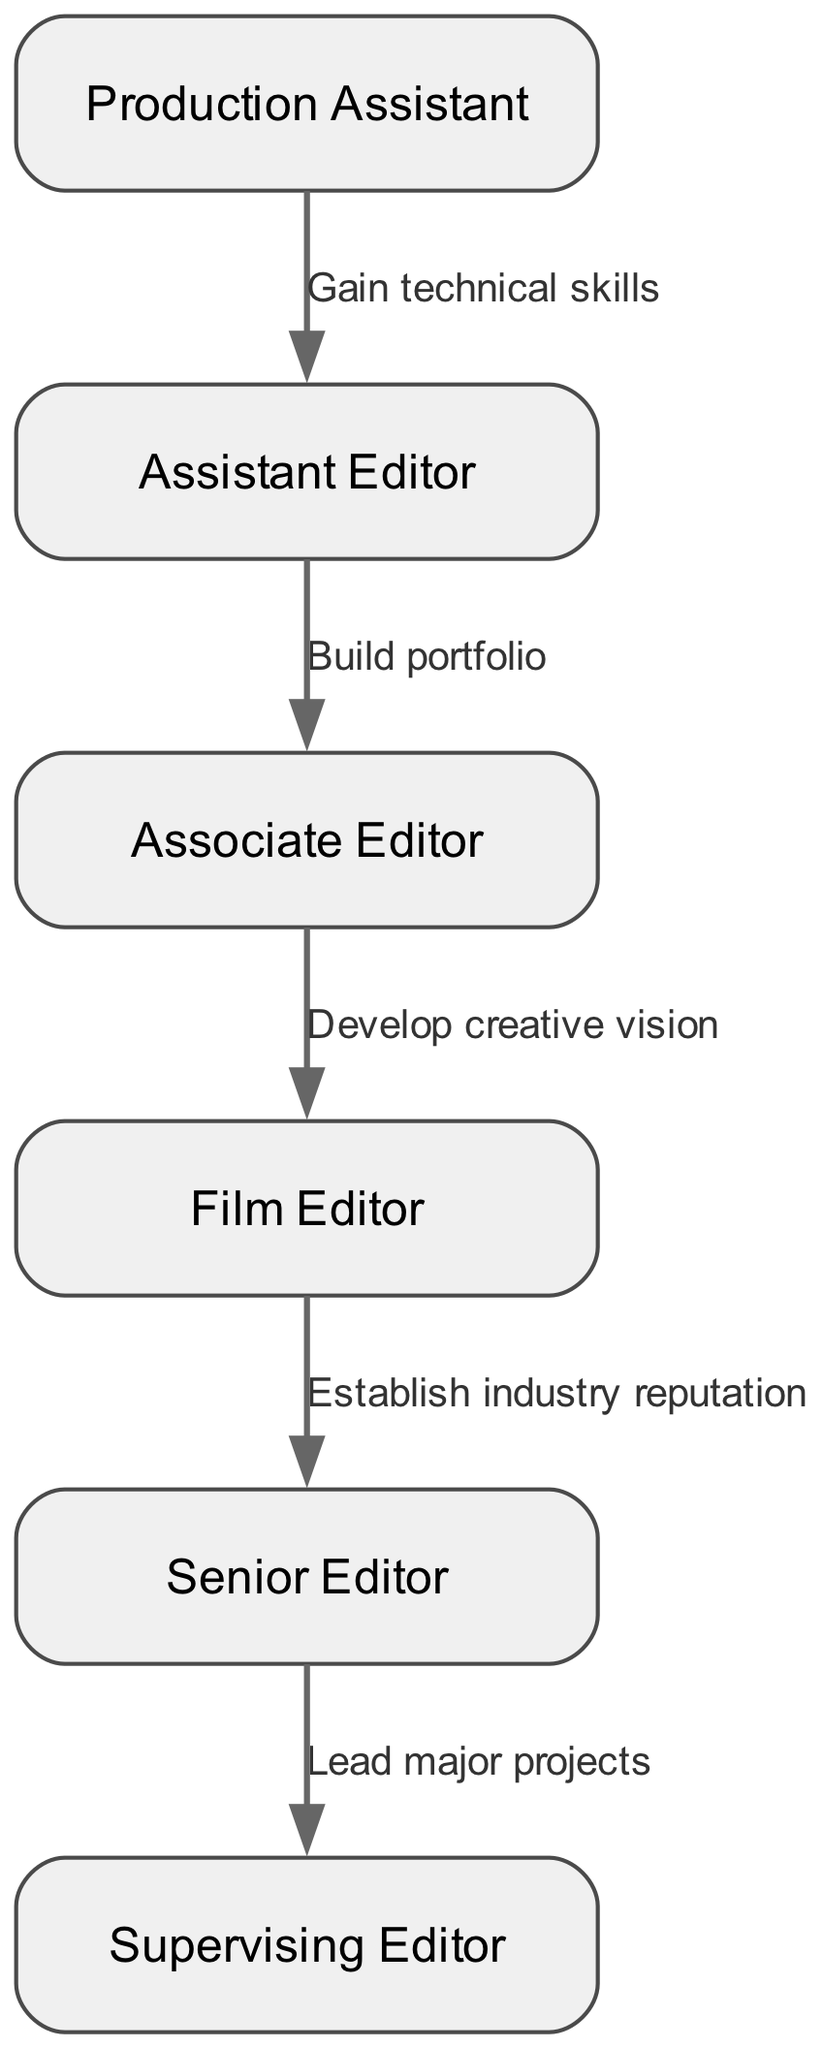What is the first role in the progression path? The diagram shows the career progression starting with the node labeled "Production Assistant", which is the initial role for aspiring film industry professionals.
Answer: Production Assistant How many nodes are in the diagram? By counting the nodes listed, we find there are six: Production Assistant, Assistant Editor, Associate Editor, Film Editor, Senior Editor, and Supervising Editor.
Answer: Six What skill is needed to move from Production Assistant to Assistant Editor? The edge connecting these two nodes indicates that one must "Gain technical skills" to progress from a Production Assistant to an Assistant Editor.
Answer: Gain technical skills What is the last role before becoming a Supervising Editor? The last node before the edge leading to Supervising Editor is labeled "Senior Editor," based on the direct connection illustrated in the diagram.
Answer: Senior Editor What must an Assistant Editor do to progress to an Associate Editor? The connection between the Assistant Editor and Associate Editor notes that one must "Build portfolio" to achieve advancement to the Associate Editor role.
Answer: Build portfolio What is the label on the edge connecting Film Editor to Senior Editor? The edge connecting these two nodes is labeled "Establish industry reputation," which indicates the key requirement for advancing from Film Editor to Senior Editor.
Answer: Establish industry reputation What indicates the transition from Associate Editor to Film Editor? The transition is marked by the edge labeled "Develop creative vision," which is necessary for moving from Associate Editor to Film Editor in the progression path.
Answer: Develop creative vision What do the edges between the nodes represent? The edges depict the necessary steps or skills required to progress from one role to another within the film industry career path as illustrated in the diagram.
Answer: Steps or skills required for progression 